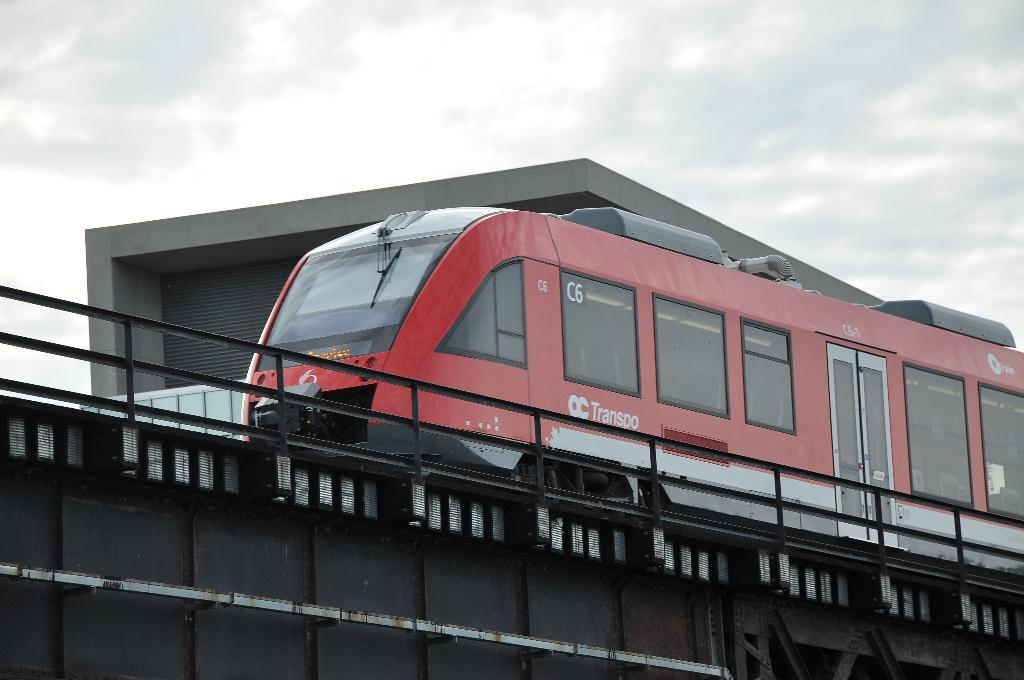What type of vehicle is in the image? There is a red color train in the image. Where is the train located? The train is on a railway track. What can be seen in the background of the image? There is a building, a fence, and the sky visible in the background of the image. Are there any other objects visible in the background? Yes, there are other objects visible in the background of the image. What type of silk is being used to force the train off the tracks in the image? There is no silk or force present in the image; the train is on a railway track without any indication of interference. 